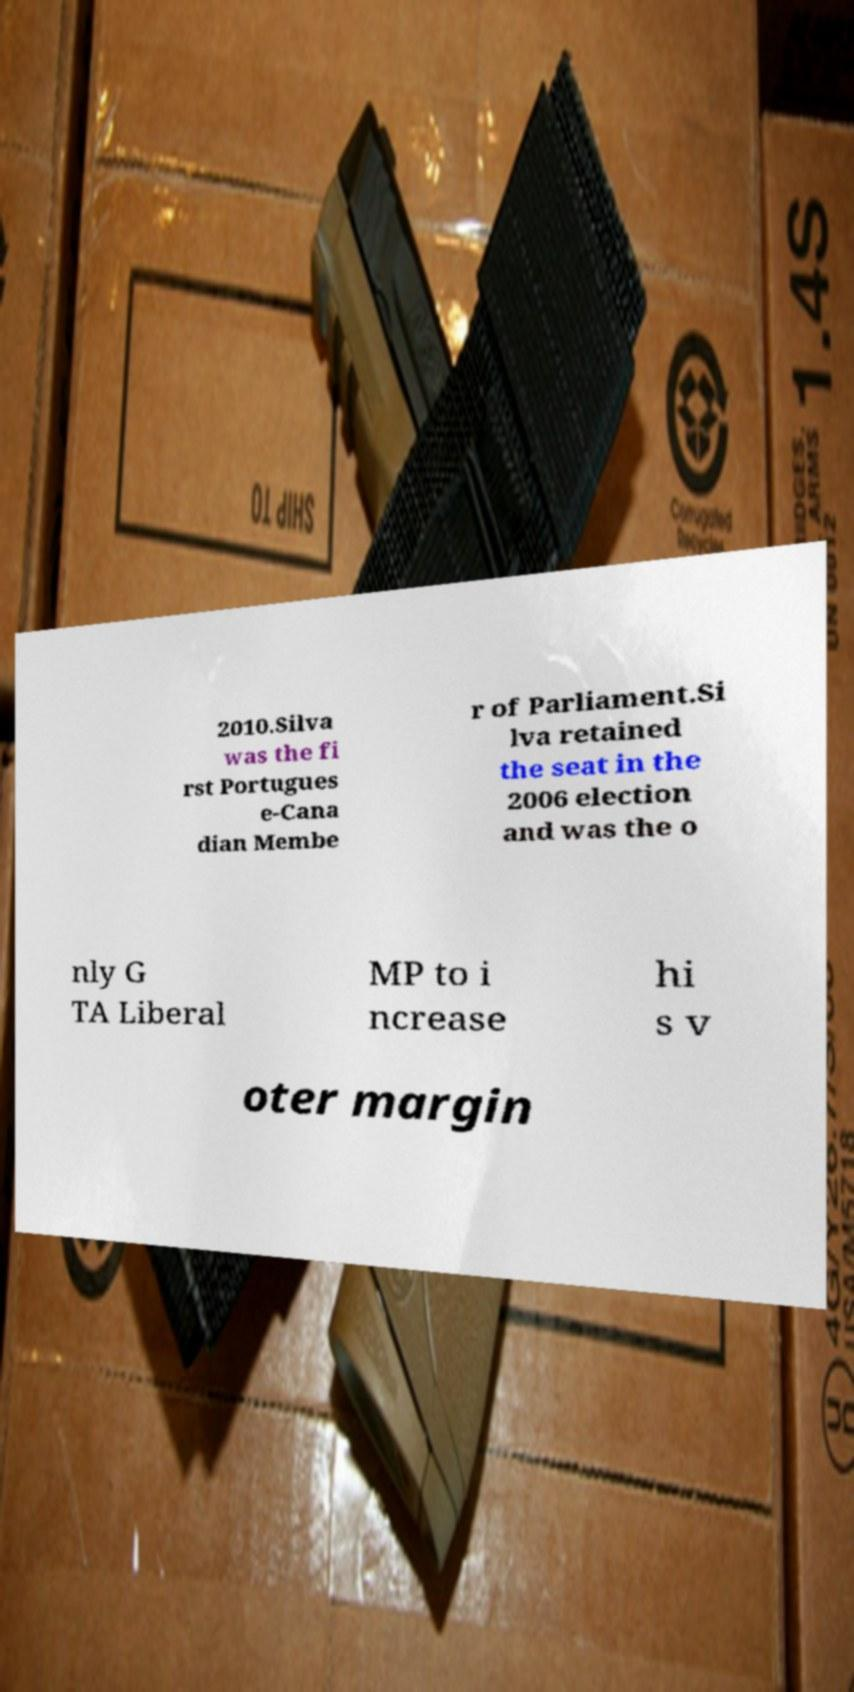There's text embedded in this image that I need extracted. Can you transcribe it verbatim? 2010.Silva was the fi rst Portugues e-Cana dian Membe r of Parliament.Si lva retained the seat in the 2006 election and was the o nly G TA Liberal MP to i ncrease hi s v oter margin 